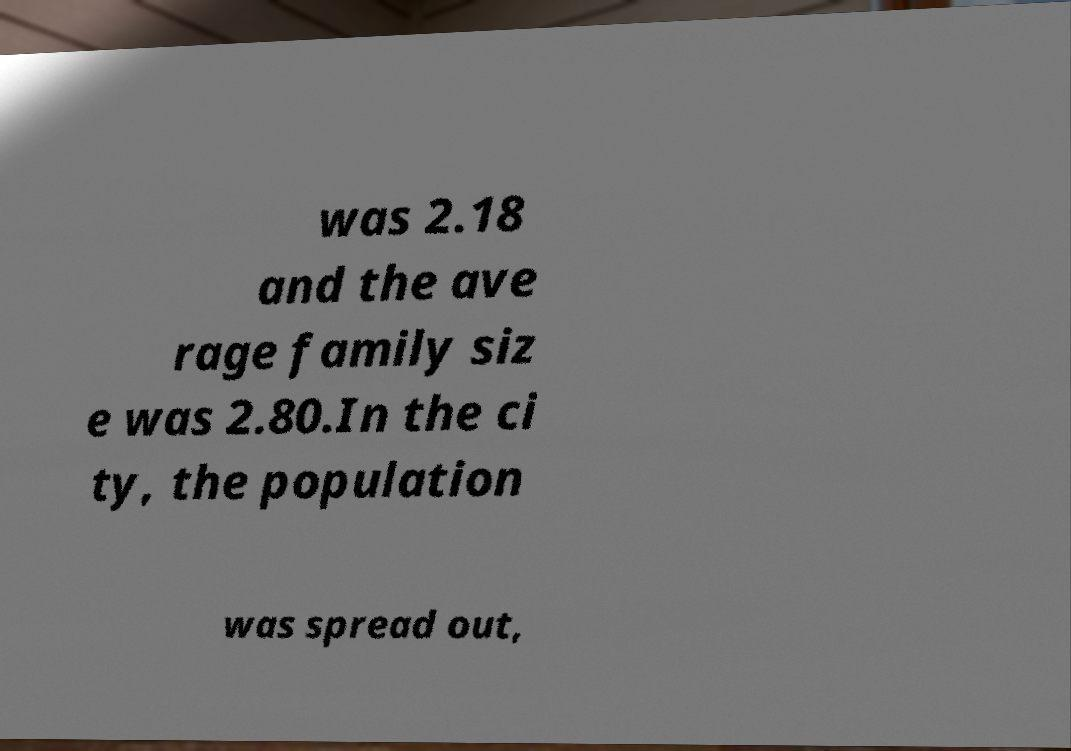For documentation purposes, I need the text within this image transcribed. Could you provide that? was 2.18 and the ave rage family siz e was 2.80.In the ci ty, the population was spread out, 